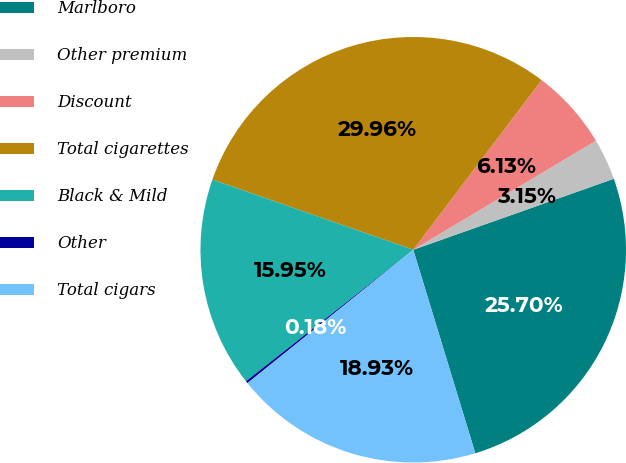<chart> <loc_0><loc_0><loc_500><loc_500><pie_chart><fcel>Marlboro<fcel>Other premium<fcel>Discount<fcel>Total cigarettes<fcel>Black & Mild<fcel>Other<fcel>Total cigars<nl><fcel>25.7%<fcel>3.15%<fcel>6.13%<fcel>29.96%<fcel>15.95%<fcel>0.18%<fcel>18.93%<nl></chart> 